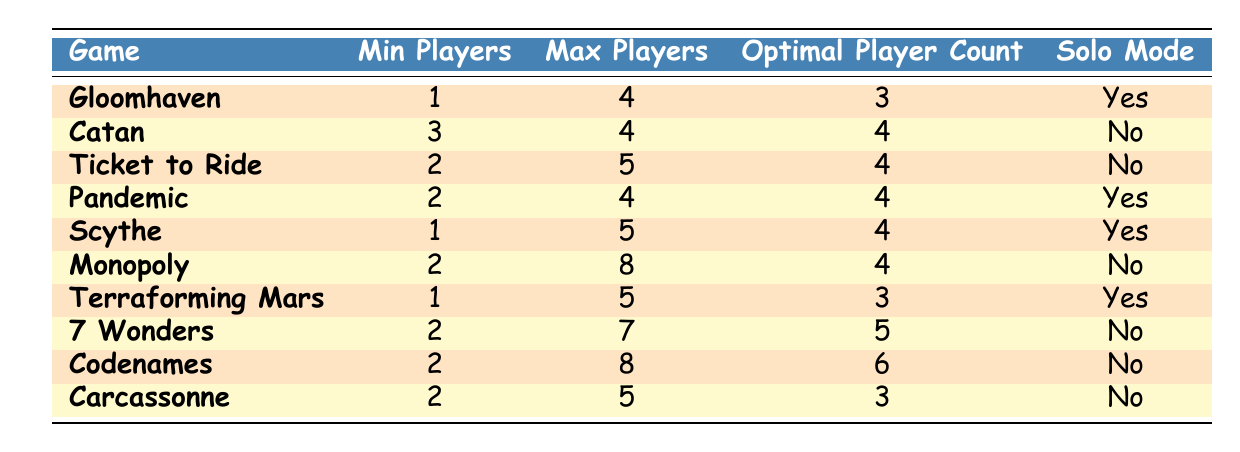What is the minimum player count for Catan? The table shows that the "Min Players" for Catan is listed as 3.
Answer: 3 Which game has the highest maximum player count? By looking at the "Max Players" column, we can compare all the values. Monopoly has the highest maximum player count of 8.
Answer: 8 Do all the games listed have a solo mode? The table contains a "Solo Mode" column indicating "Yes" or "No." Not all games have a solo mode; for example, Catan and Monopoly have "No."
Answer: No What is the optimal player count for Pandemic? Referring to the "Optimal Player Count" column for Pandemic, the value is 4.
Answer: 4 How many games can be played with 2 players as the minimum? By filtering the "Min Players" column for the value of 2, we find that there are four games: Ticket to Ride, Pandemic, Monopoly, and 7 Wonders.
Answer: 4 What is the average optimal player count for the games that have a solo mode? The optimal player counts for games with a solo mode are 3 (Gloomhaven), 4 (Pandemic), 4 (Scythe), and 3 (Terraforming Mars). The sum is 3 + 4 + 4 + 3 = 14, and there are 4 games, so the average is 14/4 = 3.5.
Answer: 3.5 Are there any games that can be played with a maximum of 4 players? The table reveals that Catan and Pandemic both have a maximum of 4 players.
Answer: Yes What is the difference between the maximum and minimum player counts for Scythe? For Scythe, the maximum player count is 5 and the minimum is 1. The difference is 5 - 1 = 4.
Answer: 4 How many games can accommodate 5 or more players? Looking at the "Max Players" column, the games that accommodate 5 or more players are Ticket to Ride, Scythe, 7 Wonders, Codenames, and Monopoly. This gives us a total of 5 games.
Answer: 5 